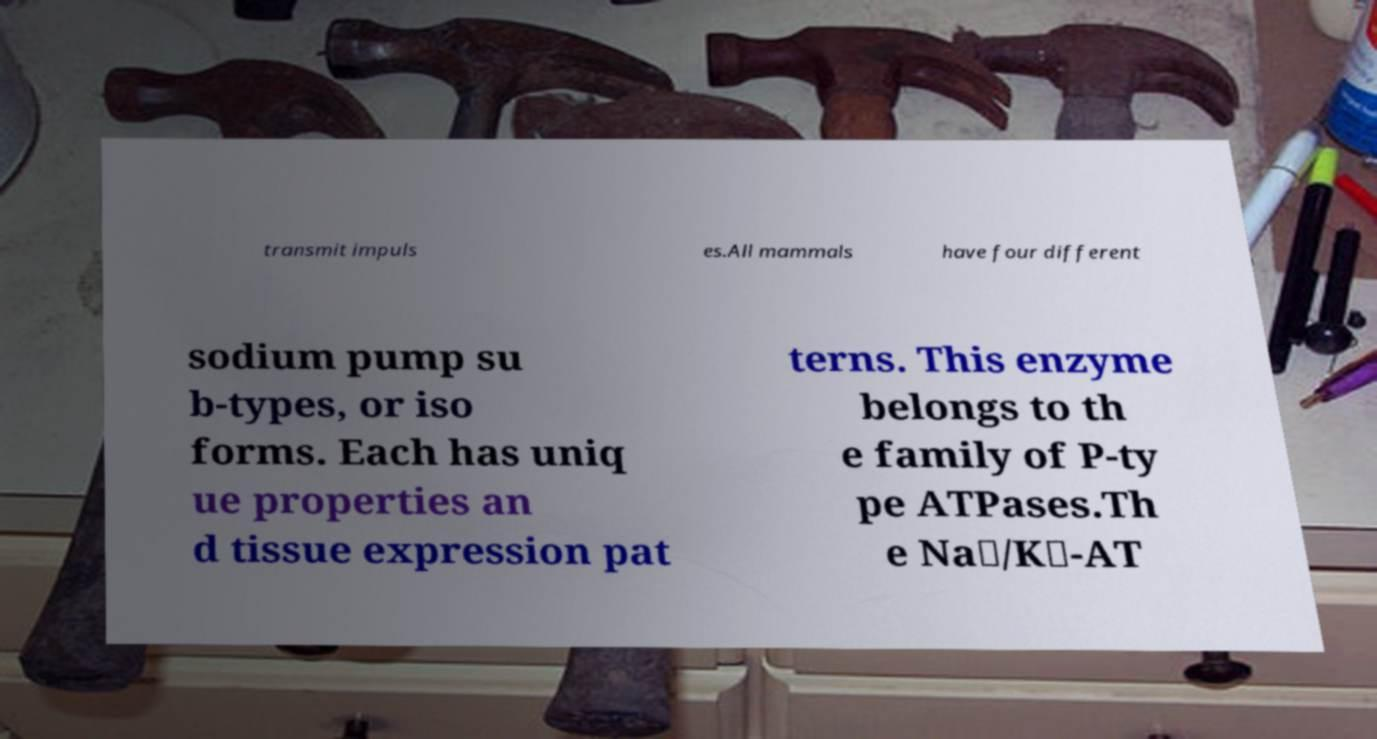Can you accurately transcribe the text from the provided image for me? transmit impuls es.All mammals have four different sodium pump su b-types, or iso forms. Each has uniq ue properties an d tissue expression pat terns. This enzyme belongs to th e family of P-ty pe ATPases.Th e Na⁺/K⁺-AT 